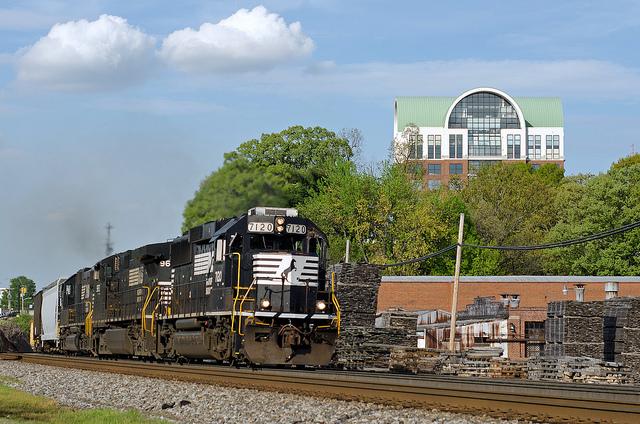What vehicle is shown?
Quick response, please. Train. What is the first number on the train?
Write a very short answer. 7. How many puffy clouds are in the sky?
Be succinct. 2. Is there a person on the train?
Give a very brief answer. Yes. 